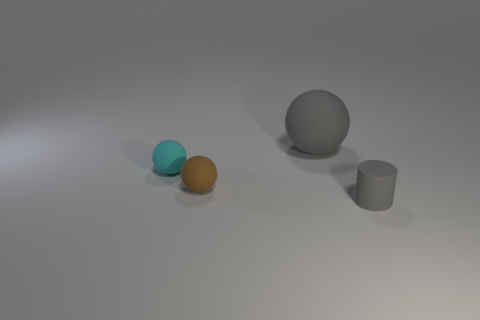What is the material of the ball that is the same color as the small cylinder?
Ensure brevity in your answer.  Rubber. Is there any other thing that is the same shape as the tiny gray matte thing?
Provide a succinct answer. No. Is there anything else that is the same size as the gray matte sphere?
Provide a short and direct response. No. What is the color of the tiny sphere in front of the cyan rubber sphere on the left side of the large matte sphere?
Your answer should be very brief. Brown. There is a big gray matte thing; what shape is it?
Your answer should be very brief. Sphere. Does the rubber ball on the left side of the brown thing have the same size as the large gray sphere?
Make the answer very short. No. Is there a small cyan ball made of the same material as the tiny brown ball?
Give a very brief answer. Yes. What number of things are either gray spheres behind the rubber cylinder or small matte spheres?
Provide a short and direct response. 3. Are there any purple shiny objects?
Ensure brevity in your answer.  No. The rubber object that is on the right side of the small brown thing and on the left side of the gray rubber cylinder has what shape?
Provide a succinct answer. Sphere. 